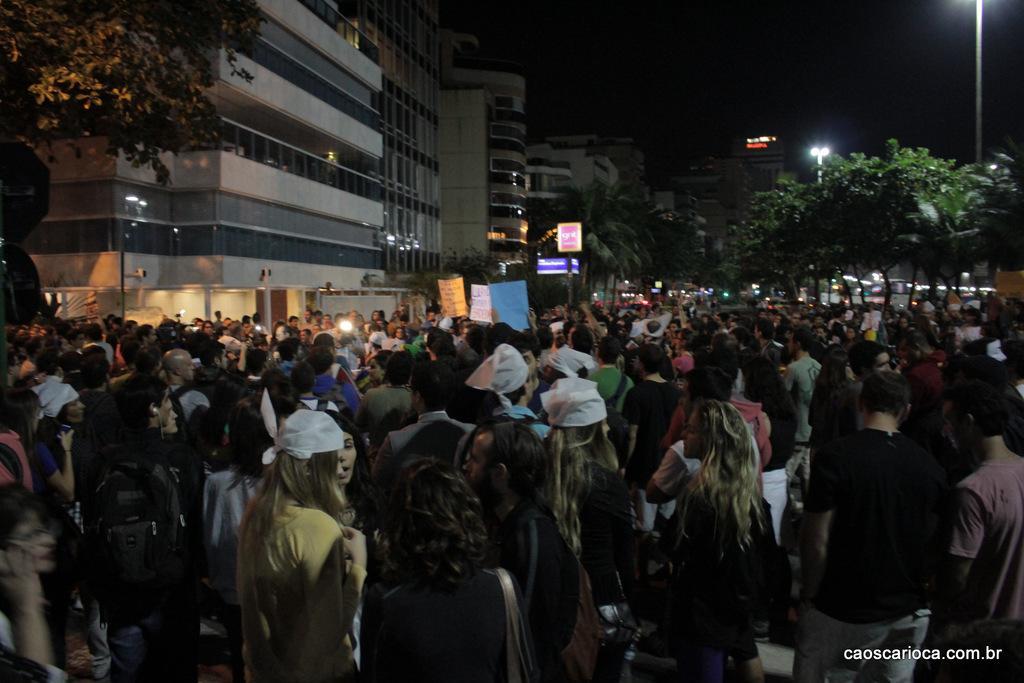Can you describe this image briefly? In the image there are many people standing. And they are holding posters in their hands. Behind them there are buildings with walls and glasses. And also there are trees and poles with lights. In the bottom right corner of the image there is something written on it. 